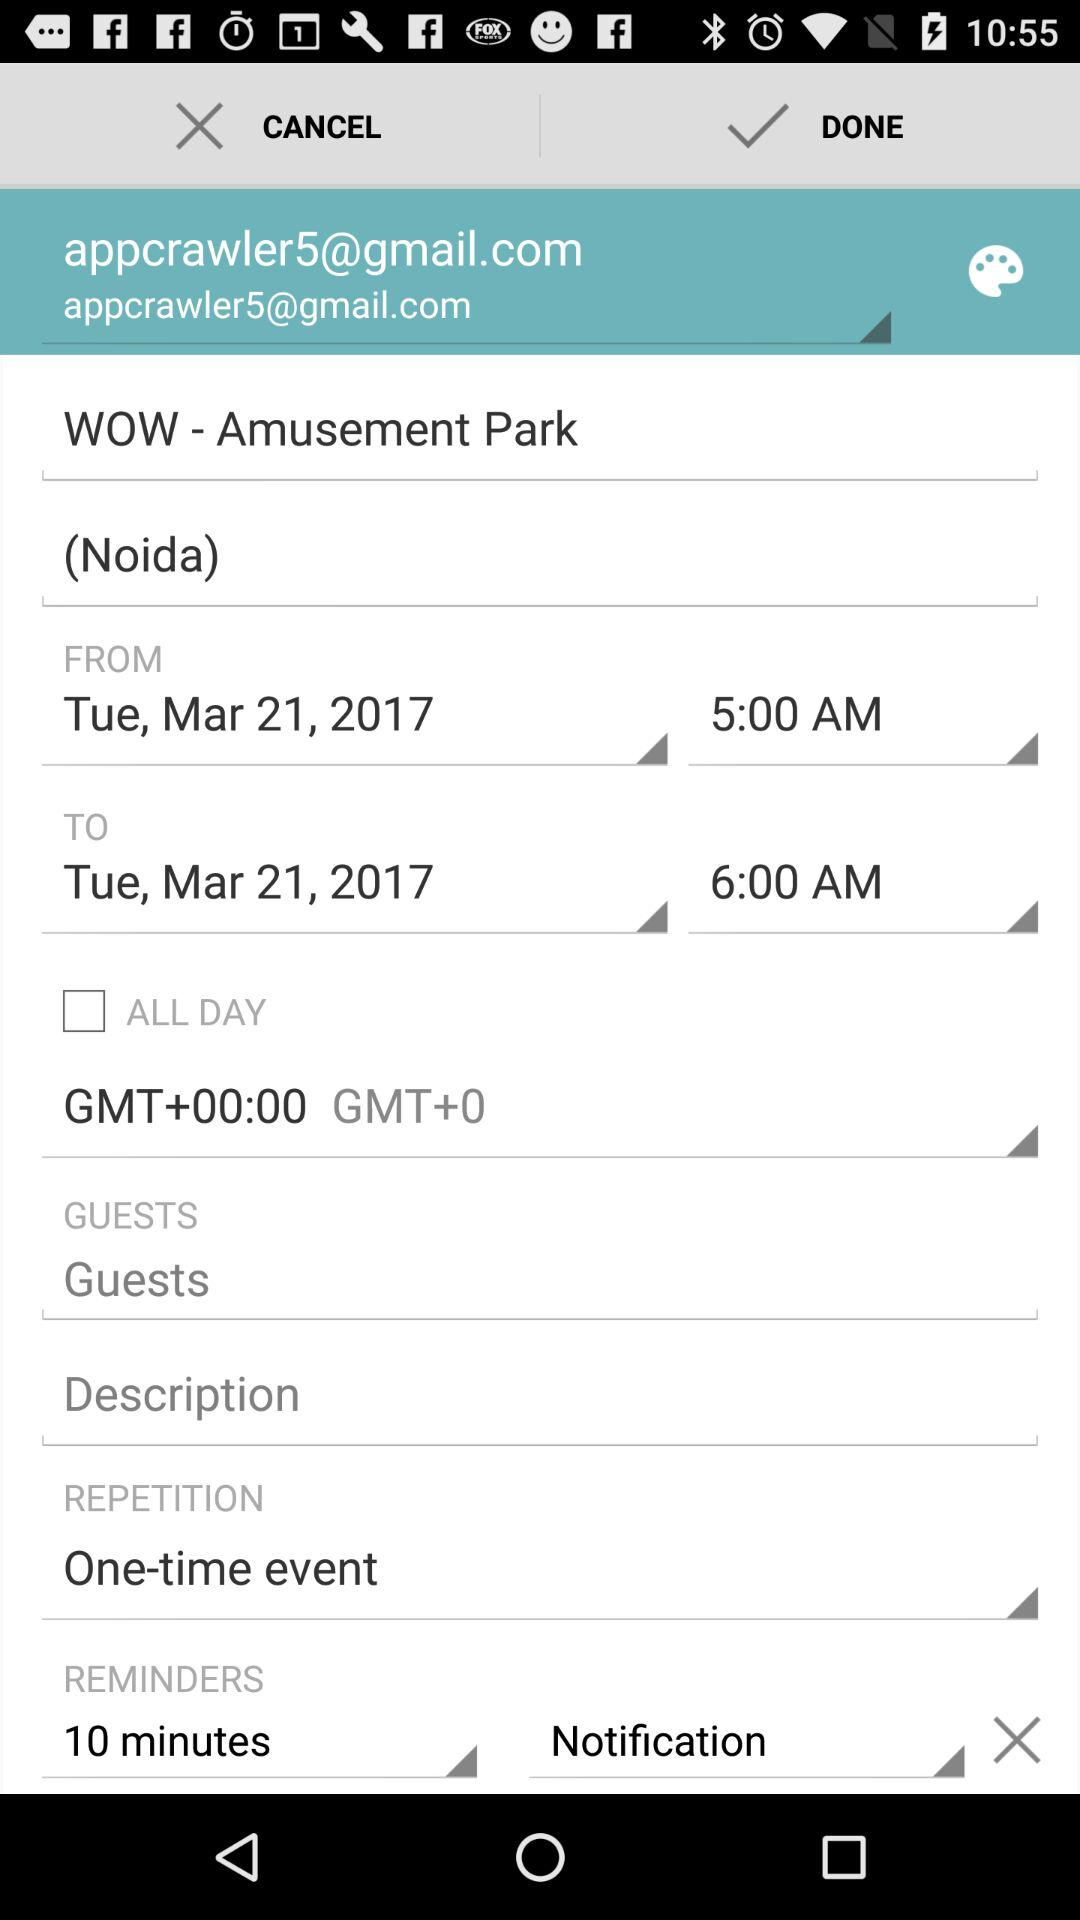What's the amusement park's name and location? The amusement park's name is "WOW" and the location is Noida. 